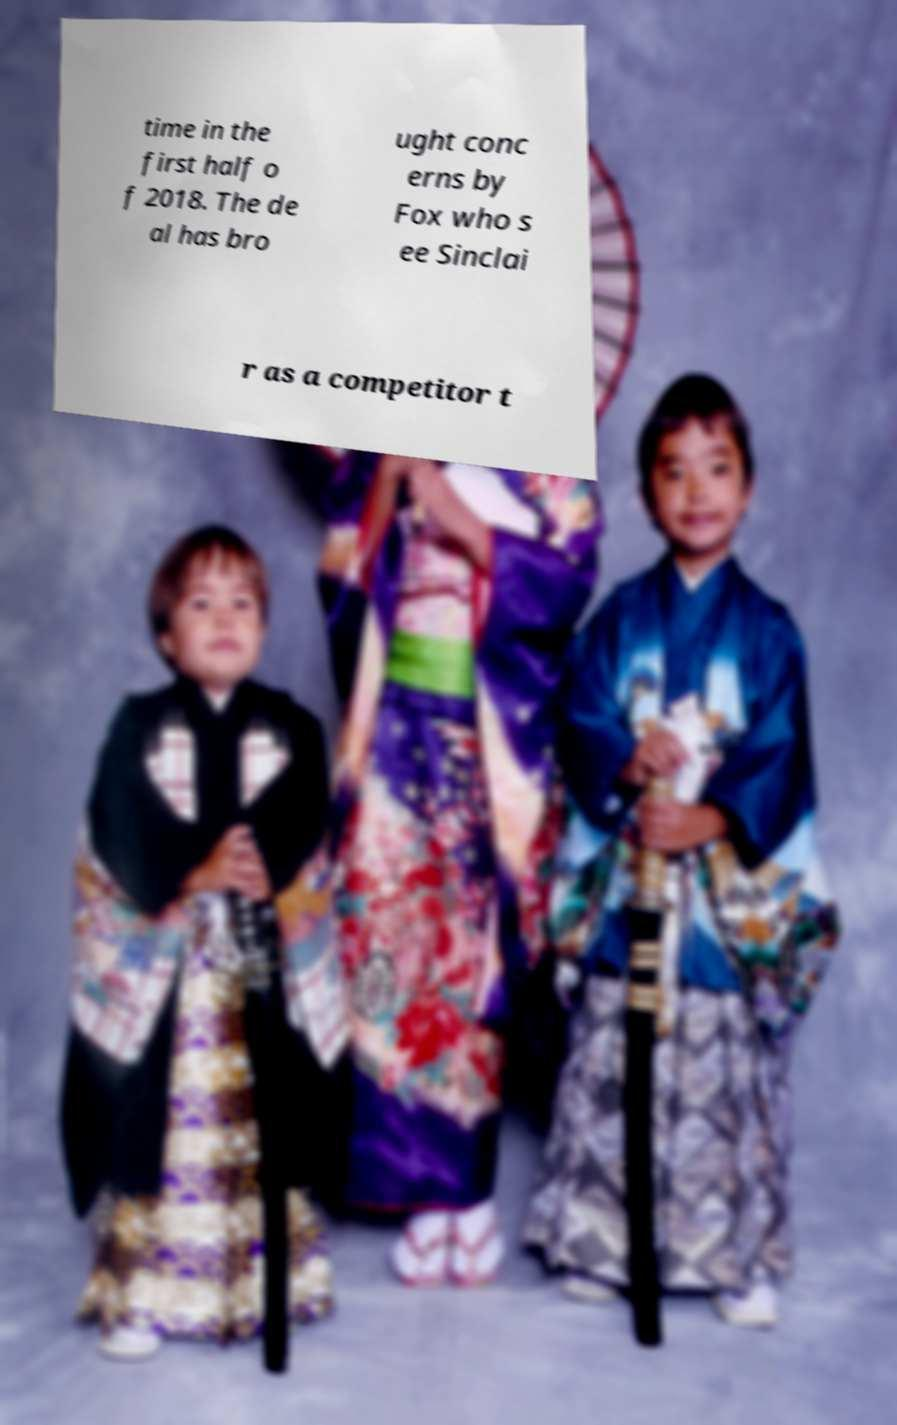Can you read and provide the text displayed in the image?This photo seems to have some interesting text. Can you extract and type it out for me? time in the first half o f 2018. The de al has bro ught conc erns by Fox who s ee Sinclai r as a competitor t 